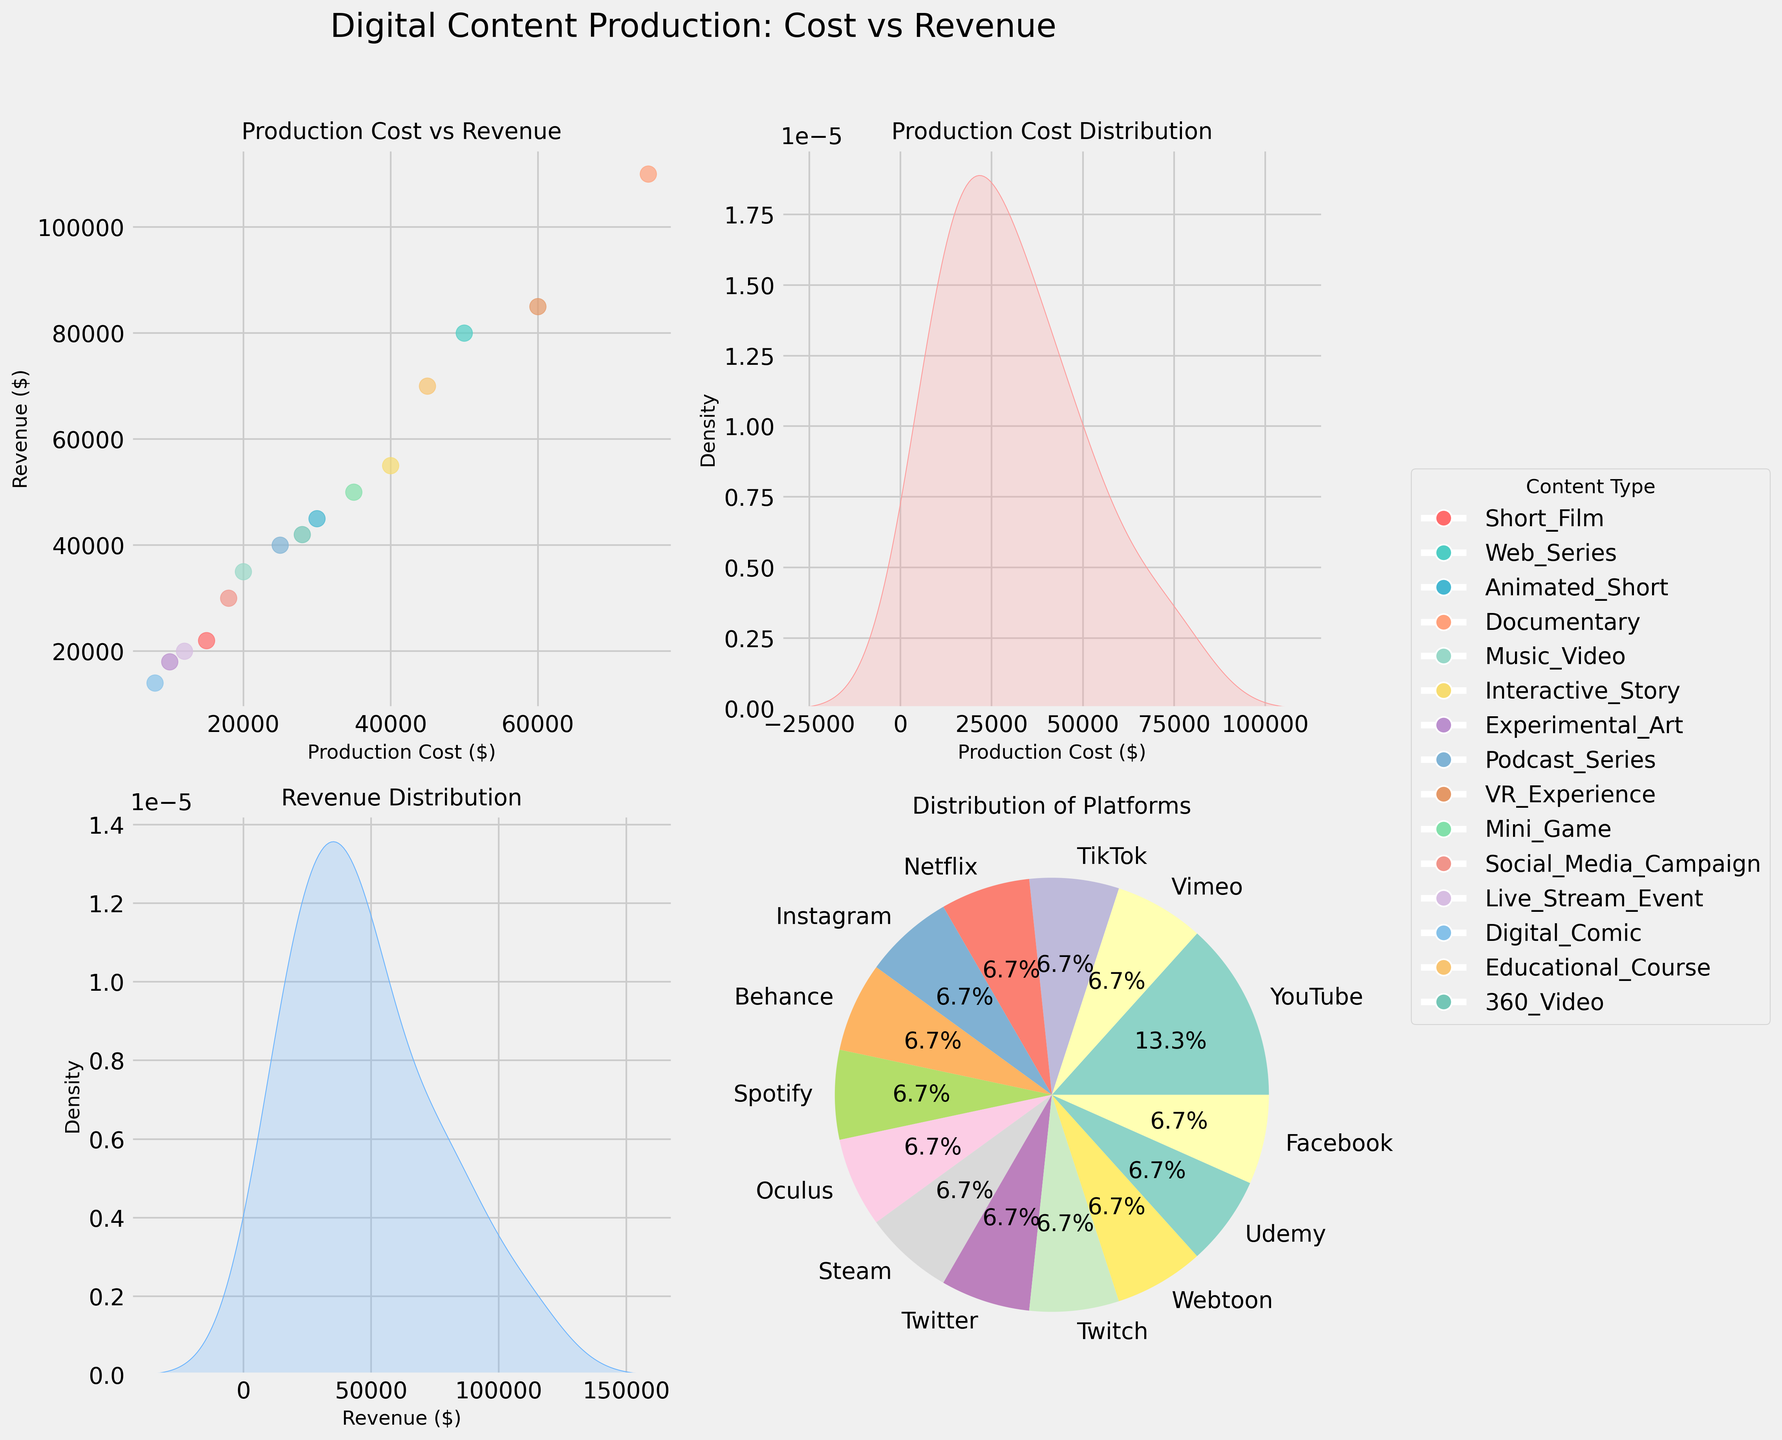What is the title of the scatter plot matrix? The title is displayed at the top center of the figure. It states "Digital Content Production: Cost vs Revenue".
Answer: Digital Content Production: Cost vs Revenue Which content type has the highest production cost? In the scatter plot (upper left), locate the highest data point on the x-axis (Production Cost). The highest value is for "Documentary" with a cost of $75,000.
Answer: Documentary How is the platform distribution depicted? In the lower-right section, there's a pie chart showing percentages of different platforms. Each segment is labeled with platform names and percentages.
Answer: Pie chart What is the approximate highest revenue recorded, and for which content type? In the scatter plot (upper left), identify the highest point on the y-axis (Revenue). The highest revenue is approximately $110,000 for "Documentary".
Answer: $110,000, Documentary Between "Web Series" and "Mini Game," which one has a higher revenue? By comparing the points for "Web Series" and "Mini Game" in the scatter plot, "Web Series" has a revenue of $80,000, higher than "Mini Game" with $50,000.
Answer: Web Series What's the color used to represent "Music Video"? Refer to the legend on the side of the figure; "Music Video" is represented by a light greenish color.
Answer: light green What is the median production cost across all content types? To find the median, list all production costs: $15000, $50000, $30000, $75000, $20000, $40000, $10000, $25000, $60000, $35000, $18000, $12000, $8000, $45000, $28000. The middle value in this sorted list is $28000.
Answer: $28000 Which platform hosts the most diverse types of content? Check the pie chart (lower right) to see which platform has the largest segment or number of segments. YouTube has the largest percentage, suggesting it hosts a variety of content types.
Answer: YouTube How does the production cost distribution look like? In the upper-right section, there's a distribution plot with a high peak around $30,000, indicating it's a common production cost.
Answer: Peaks around $30,000 Which has a greater distribution spread, Production Cost or Revenue? By comparing the KDE plots, the production cost distribution (upper right) appears more spread out compared to the revenue distribution (lower left).
Answer: Production Cost 